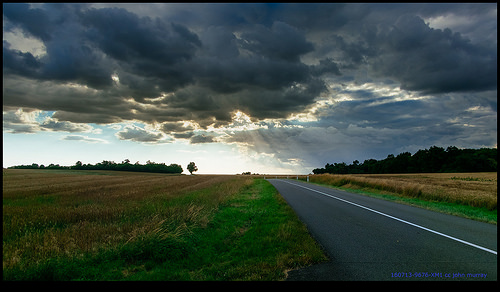<image>
Can you confirm if the road is to the left of the sky? No. The road is not to the left of the sky. From this viewpoint, they have a different horizontal relationship. Is the road under the sky? Yes. The road is positioned underneath the sky, with the sky above it in the vertical space. 